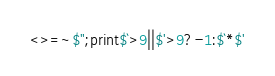<code> <loc_0><loc_0><loc_500><loc_500><_Perl_><>=~$";print$`>9||$'>9?-1:$`*$'</code> 